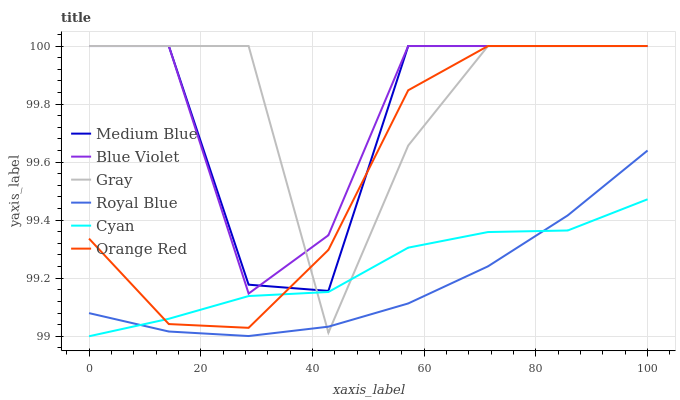Does Royal Blue have the minimum area under the curve?
Answer yes or no. Yes. Does Gray have the maximum area under the curve?
Answer yes or no. Yes. Does Medium Blue have the minimum area under the curve?
Answer yes or no. No. Does Medium Blue have the maximum area under the curve?
Answer yes or no. No. Is Royal Blue the smoothest?
Answer yes or no. Yes. Is Medium Blue the roughest?
Answer yes or no. Yes. Is Medium Blue the smoothest?
Answer yes or no. No. Is Royal Blue the roughest?
Answer yes or no. No. Does Cyan have the lowest value?
Answer yes or no. Yes. Does Royal Blue have the lowest value?
Answer yes or no. No. Does Blue Violet have the highest value?
Answer yes or no. Yes. Does Royal Blue have the highest value?
Answer yes or no. No. Is Royal Blue less than Blue Violet?
Answer yes or no. Yes. Is Medium Blue greater than Cyan?
Answer yes or no. Yes. Does Royal Blue intersect Gray?
Answer yes or no. Yes. Is Royal Blue less than Gray?
Answer yes or no. No. Is Royal Blue greater than Gray?
Answer yes or no. No. Does Royal Blue intersect Blue Violet?
Answer yes or no. No. 